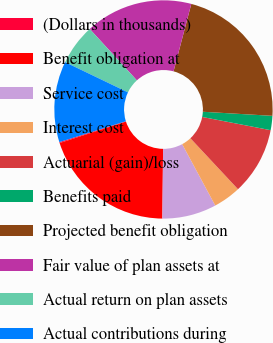Convert chart to OTSL. <chart><loc_0><loc_0><loc_500><loc_500><pie_chart><fcel>(Dollars in thousands)<fcel>Benefit obligation at<fcel>Service cost<fcel>Interest cost<fcel>Actuarial (gain)/loss<fcel>Benefits paid<fcel>Projected benefit obligation<fcel>Fair value of plan assets at<fcel>Actual return on plan assets<fcel>Actual contributions during<nl><fcel>0.14%<fcel>19.86%<fcel>8.03%<fcel>4.09%<fcel>10.0%<fcel>2.11%<fcel>21.83%<fcel>15.91%<fcel>6.06%<fcel>11.97%<nl></chart> 